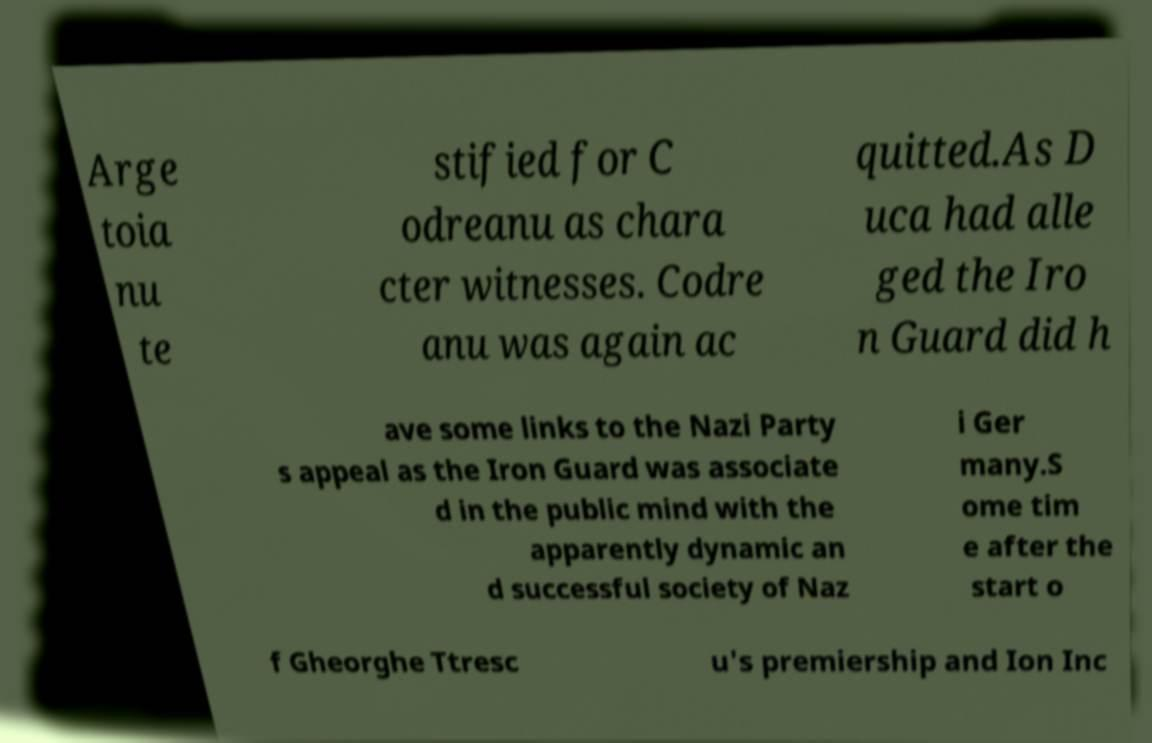Please read and relay the text visible in this image. What does it say? Arge toia nu te stified for C odreanu as chara cter witnesses. Codre anu was again ac quitted.As D uca had alle ged the Iro n Guard did h ave some links to the Nazi Party s appeal as the Iron Guard was associate d in the public mind with the apparently dynamic an d successful society of Naz i Ger many.S ome tim e after the start o f Gheorghe Ttresc u's premiership and Ion Inc 